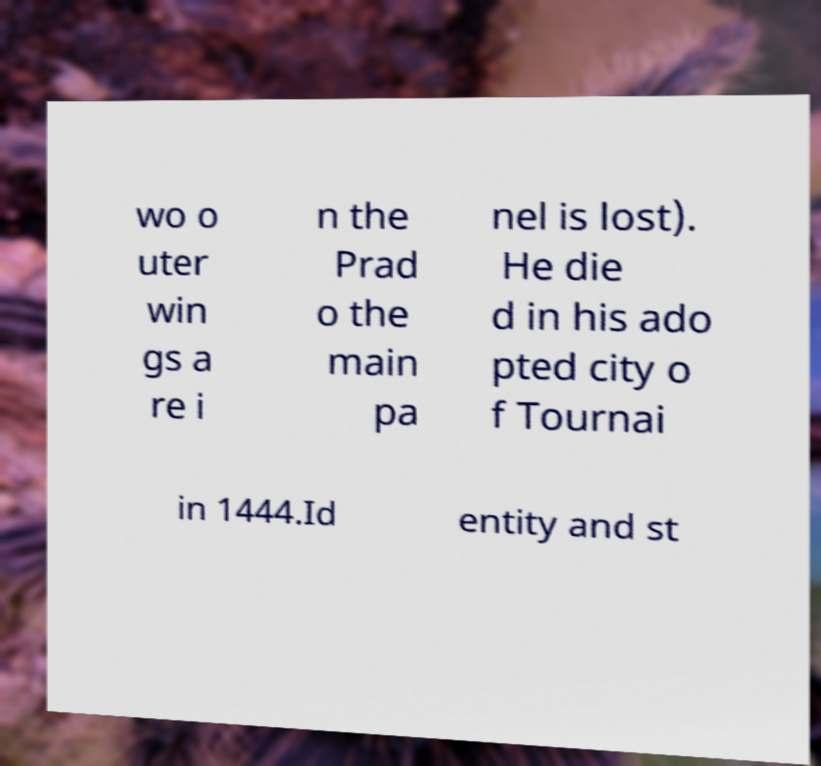Could you extract and type out the text from this image? wo o uter win gs a re i n the Prad o the main pa nel is lost). He die d in his ado pted city o f Tournai in 1444.Id entity and st 